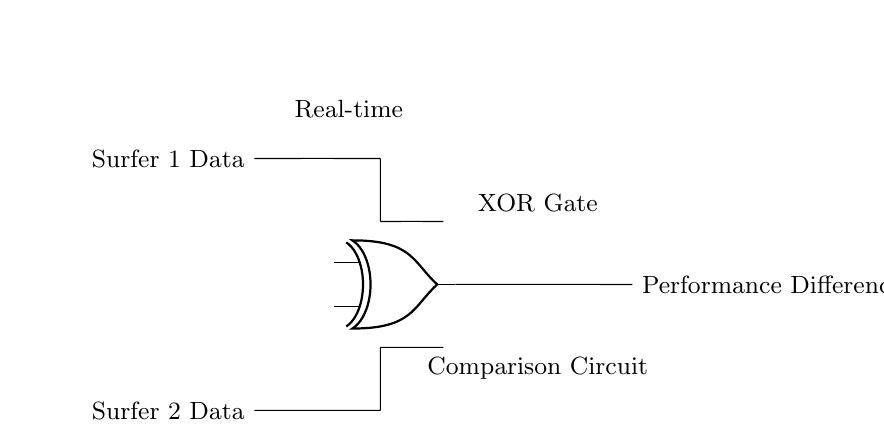what are the inputs to the XOR gate? The circuit diagram indicates that the inputs to the XOR gate are labeled "Surfer 1 Data" and "Surfer 2 Data." These are directly connected as input signals to the XOR gate.
Answer: Surfer 1 Data, Surfer 2 Data what is the output of the XOR gate? The output of the XOR gate is labeled as "Performance Difference." This indicates that the XOR gate outputs the performance difference based on the inputs provided.
Answer: Performance Difference how many inputs does the XOR gate have? The circuit shows that there are two distinct input lines leading to the XOR gate, which correspond to the data from two competitors.
Answer: 2 what kind of circuit is represented? The diagram depicts a logic circuit specifically designed for comparison using an XOR gate to evaluate performance data. This is characteristic of digital logic circuits.
Answer: Logic Circuit why is an XOR gate used in this circuit? The XOR gate is specifically chosen because it outputs a true value when the inputs differ, making it suitable for comparing performance data of two surfers. If one surfer outperforms the other, the XOR will indicate that difference as a positive output.
Answer: To compare performance data what does the label "Real-time" signify in the circuit? The label "Real-time" denotes that the performance data being fed into the XOR gate is processed instantly, showing immediate comparison results as the data come in.
Answer: Instant processing which component compares the performance data between the two surfers? The XOR gate is the component specifically designed to compare the performance data, producing an output based on the two input signals from the surfers.
Answer: XOR gate 